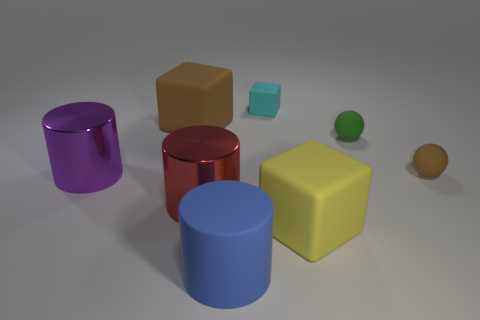There is a tiny block; are there any rubber spheres behind it?
Make the answer very short. No. The big rubber cylinder has what color?
Keep it short and to the point. Blue. There is a matte cylinder; is its color the same as the tiny matte object that is behind the small green sphere?
Offer a very short reply. No. Are there any purple balls that have the same size as the red cylinder?
Ensure brevity in your answer.  No. There is a big cylinder that is behind the red object; what is its material?
Keep it short and to the point. Metal. Are there an equal number of large red metal cylinders that are behind the red shiny cylinder and small things right of the tiny green object?
Provide a succinct answer. No. There is a metallic thing that is on the left side of the big brown rubber thing; is it the same size as the red cylinder that is in front of the large purple cylinder?
Your answer should be compact. Yes. How many large rubber cylinders have the same color as the tiny matte cube?
Provide a succinct answer. 0. Are there more blue cylinders on the left side of the rubber cylinder than red shiny cylinders?
Keep it short and to the point. No. Is the shape of the small cyan matte object the same as the purple shiny object?
Ensure brevity in your answer.  No. 